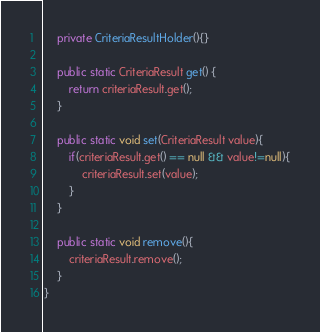<code> <loc_0><loc_0><loc_500><loc_500><_Java_>
    private CriteriaResultHolder(){}

    public static CriteriaResult get() {
        return criteriaResult.get();
    }

    public static void set(CriteriaResult value){
        if(criteriaResult.get() == null && value!=null){
            criteriaResult.set(value);
        }
    }

    public static void remove(){
        criteriaResult.remove();
    }
}
</code> 